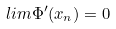Convert formula to latex. <formula><loc_0><loc_0><loc_500><loc_500>l i m \Phi ^ { \prime } ( x _ { n } ) = 0</formula> 